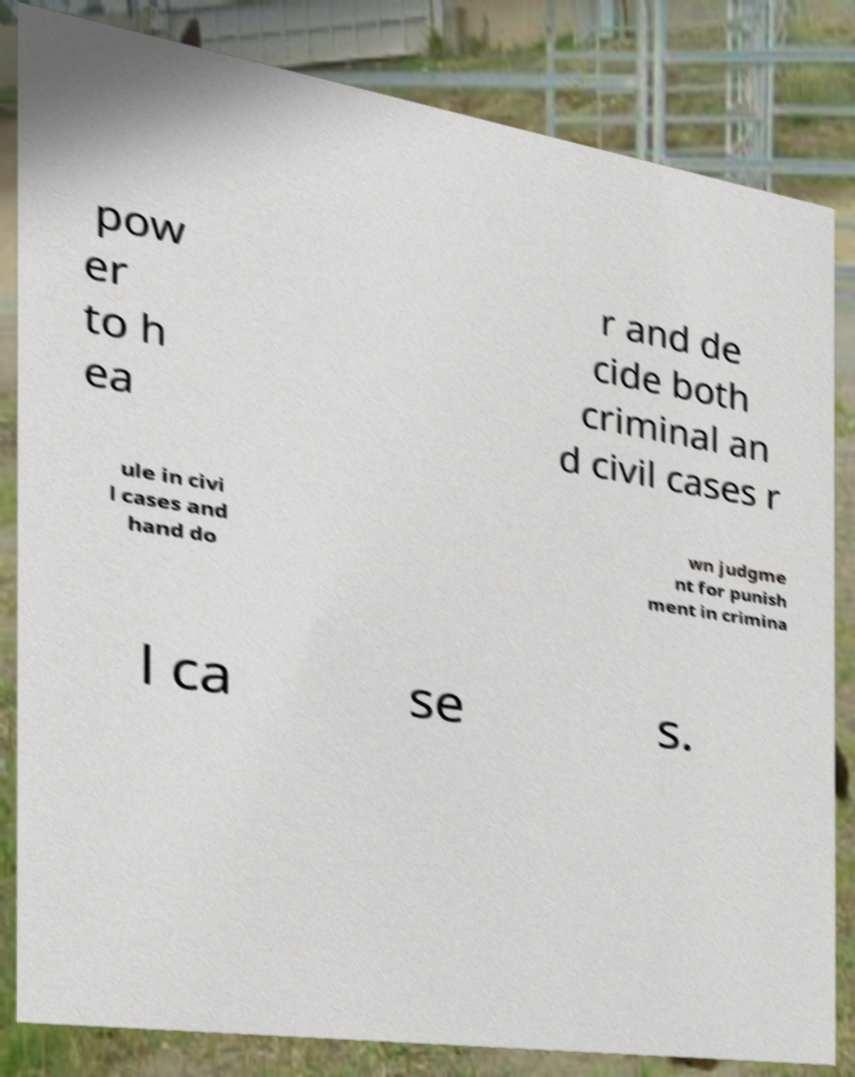Please identify and transcribe the text found in this image. pow er to h ea r and de cide both criminal an d civil cases r ule in civi l cases and hand do wn judgme nt for punish ment in crimina l ca se s. 